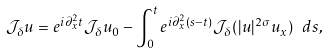Convert formula to latex. <formula><loc_0><loc_0><loc_500><loc_500>\mathcal { J } _ { \delta } u = e ^ { i \partial _ { x } ^ { 2 } t } \mathcal { J } _ { \delta } u _ { 0 } - \int _ { 0 } ^ { t } e ^ { i \partial _ { x } ^ { 2 } ( s - t ) } \mathcal { J } _ { \delta } ( | u | ^ { 2 \sigma } u _ { x } ) \ d s ,</formula> 